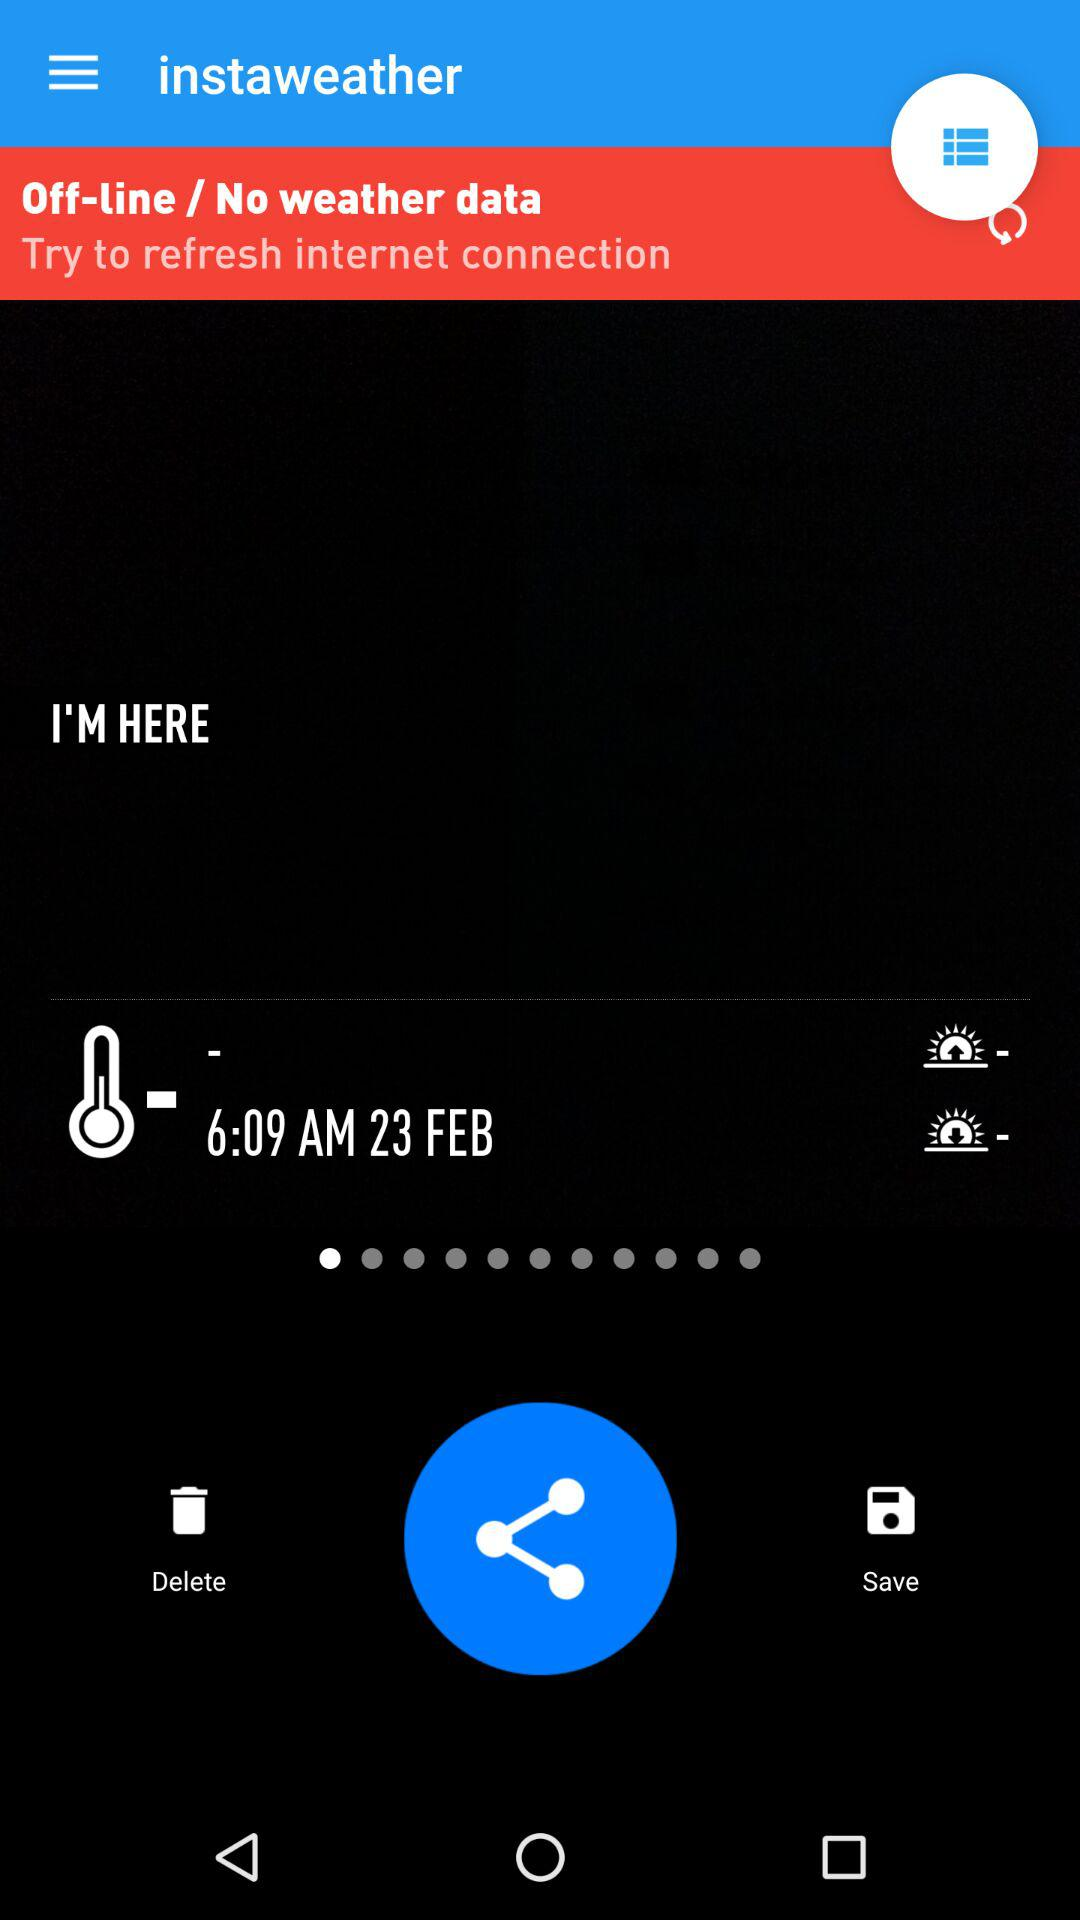What is the app title? The app title is "instaweather". 